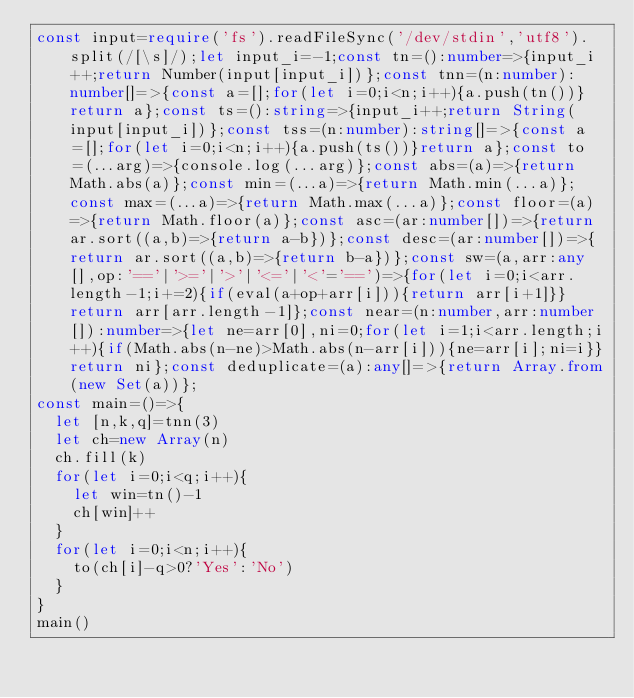Convert code to text. <code><loc_0><loc_0><loc_500><loc_500><_TypeScript_>const input=require('fs').readFileSync('/dev/stdin','utf8').split(/[\s]/);let input_i=-1;const tn=():number=>{input_i++;return Number(input[input_i])};const tnn=(n:number):number[]=>{const a=[];for(let i=0;i<n;i++){a.push(tn())}return a};const ts=():string=>{input_i++;return String(input[input_i])};const tss=(n:number):string[]=>{const a=[];for(let i=0;i<n;i++){a.push(ts())}return a};const to=(...arg)=>{console.log(...arg)};const abs=(a)=>{return Math.abs(a)};const min=(...a)=>{return Math.min(...a)};const max=(...a)=>{return Math.max(...a)};const floor=(a)=>{return Math.floor(a)};const asc=(ar:number[])=>{return ar.sort((a,b)=>{return a-b})};const desc=(ar:number[])=>{return ar.sort((a,b)=>{return b-a})};const sw=(a,arr:any[],op:'=='|'>='|'>'|'<='|'<'='==')=>{for(let i=0;i<arr.length-1;i+=2){if(eval(a+op+arr[i])){return arr[i+1]}}return arr[arr.length-1]};const near=(n:number,arr:number[]):number=>{let ne=arr[0],ni=0;for(let i=1;i<arr.length;i++){if(Math.abs(n-ne)>Math.abs(n-arr[i])){ne=arr[i];ni=i}}return ni};const deduplicate=(a):any[]=>{return Array.from(new Set(a))};
const main=()=>{
  let [n,k,q]=tnn(3)
  let ch=new Array(n)
  ch.fill(k)
  for(let i=0;i<q;i++){
    let win=tn()-1
    ch[win]++
  }
  for(let i=0;i<n;i++){
    to(ch[i]-q>0?'Yes':'No')
  }
}
main()
</code> 